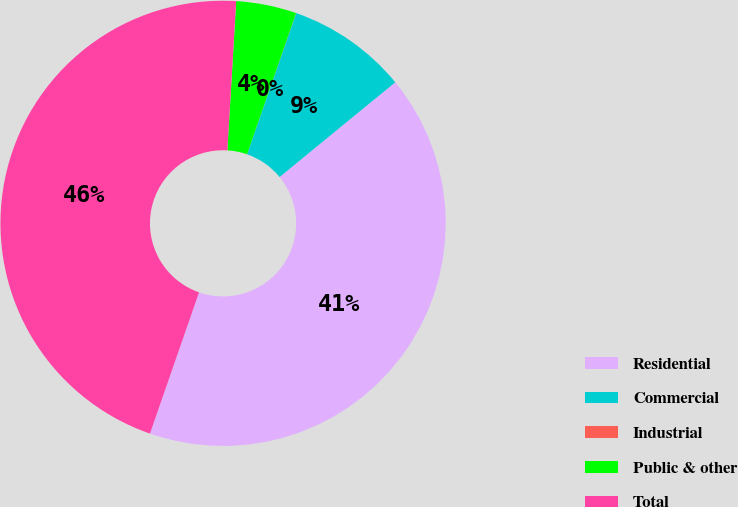Convert chart to OTSL. <chart><loc_0><loc_0><loc_500><loc_500><pie_chart><fcel>Residential<fcel>Commercial<fcel>Industrial<fcel>Public & other<fcel>Total<nl><fcel>41.25%<fcel>8.75%<fcel>0.01%<fcel>4.38%<fcel>45.62%<nl></chart> 